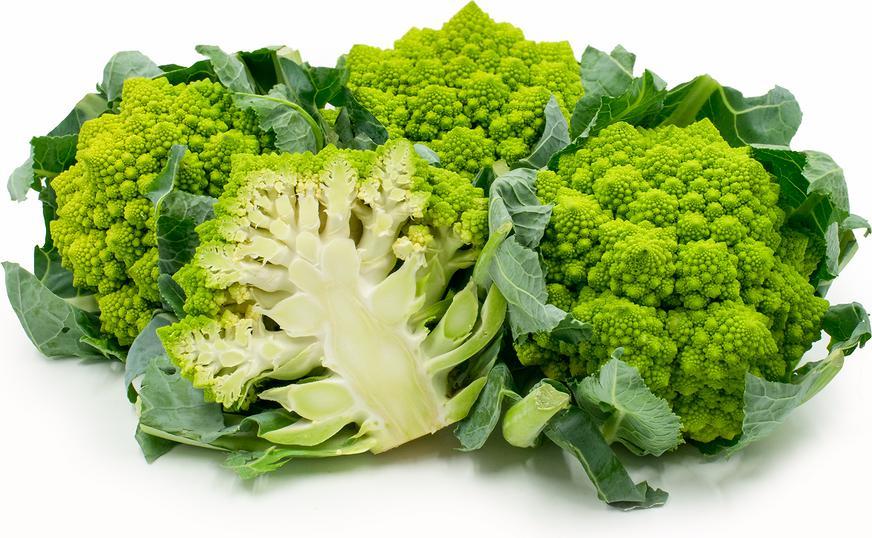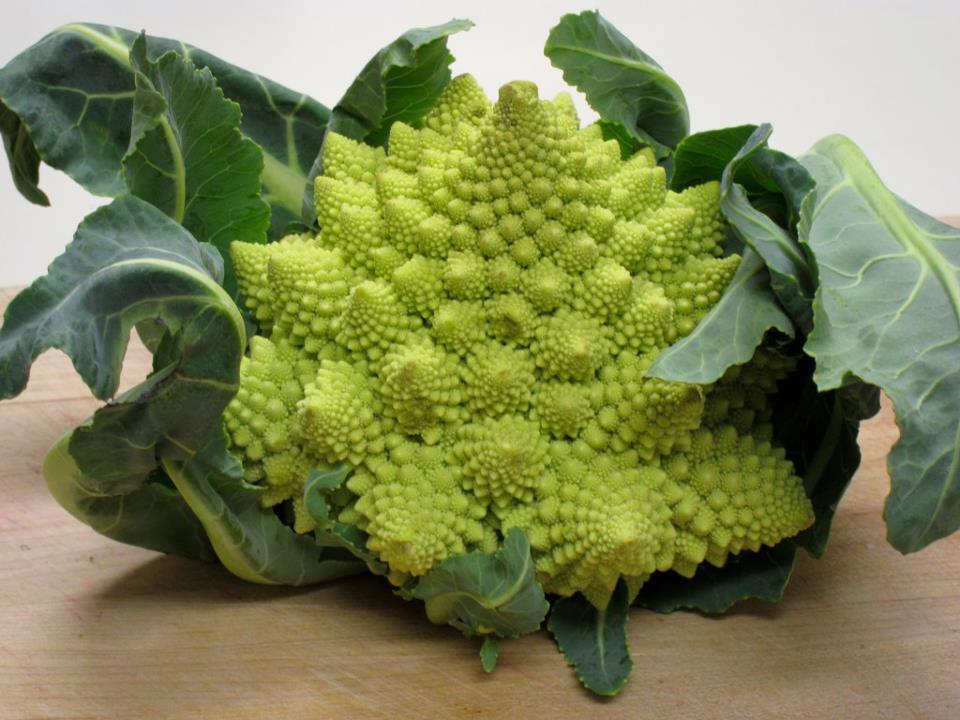The first image is the image on the left, the second image is the image on the right. Assess this claim about the two images: "The left and right image contains the same number of romanesco broccoli.". Correct or not? Answer yes or no. No. 